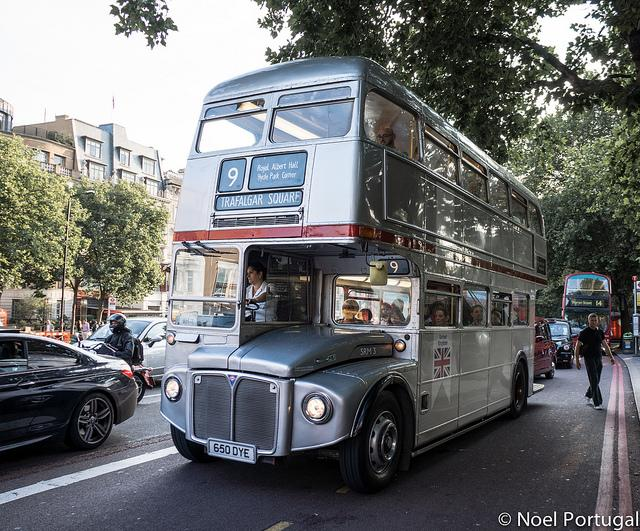In which country does this bus drive? Please explain your reasoning. united kingdom. Most double deckers are seen in england. 